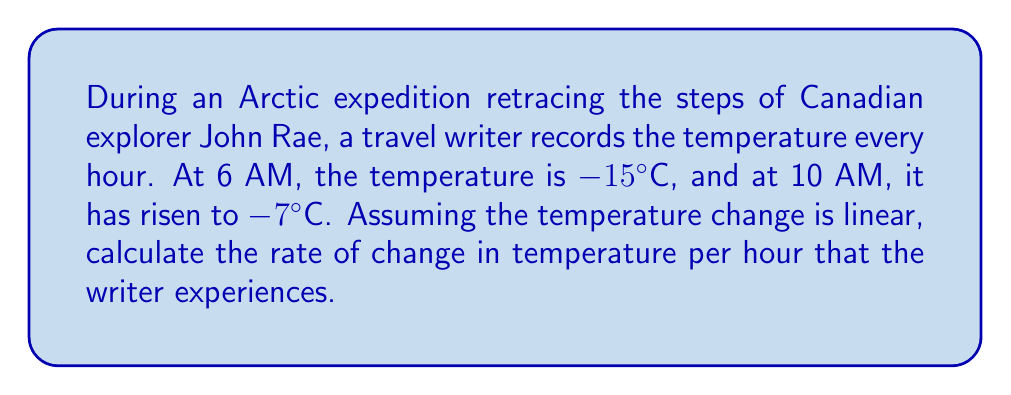What is the answer to this math problem? To solve this problem, we'll use the concept of average rate of change:

1. Identify the given information:
   - Initial time (t₁) = 6 AM
   - Initial temperature (T₁) = -15°C
   - Final time (t₂) = 10 AM
   - Final temperature (T₂) = -7°C

2. Calculate the change in temperature (ΔT):
   $$\Delta T = T_2 - T_1 = -7°C - (-15°C) = 8°C$$

3. Calculate the change in time (Δt):
   $$\Delta t = t_2 - t_1 = 10 \text{ AM} - 6 \text{ AM} = 4 \text{ hours}$$

4. Apply the average rate of change formula:
   $$\text{Rate of change} = \frac{\Delta T}{\Delta t} = \frac{8°C}{4 \text{ hours}} = 2°C/\text{hour}$$

Therefore, the travel writer experiences a temperature increase of 2°C per hour during this part of the Arctic expedition.
Answer: $2°C/\text{hour}$ 